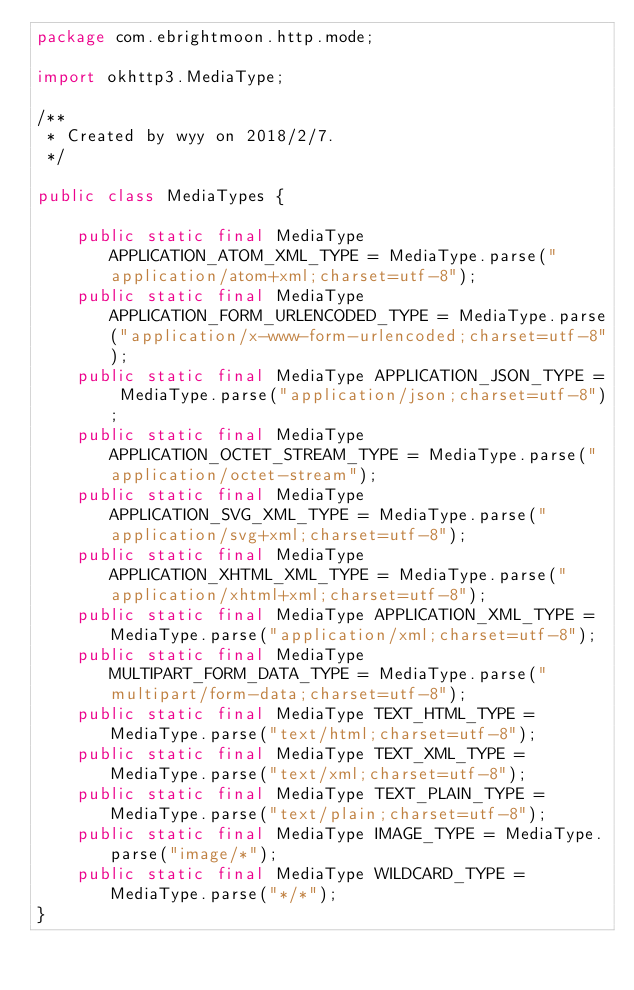<code> <loc_0><loc_0><loc_500><loc_500><_Java_>package com.ebrightmoon.http.mode;

import okhttp3.MediaType;

/**
 * Created by wyy on 2018/2/7.
 */

public class MediaTypes {

    public static final MediaType APPLICATION_ATOM_XML_TYPE = MediaType.parse("application/atom+xml;charset=utf-8");
    public static final MediaType APPLICATION_FORM_URLENCODED_TYPE = MediaType.parse("application/x-www-form-urlencoded;charset=utf-8");
    public static final MediaType APPLICATION_JSON_TYPE = MediaType.parse("application/json;charset=utf-8");
    public static final MediaType APPLICATION_OCTET_STREAM_TYPE = MediaType.parse("application/octet-stream");
    public static final MediaType APPLICATION_SVG_XML_TYPE = MediaType.parse("application/svg+xml;charset=utf-8");
    public static final MediaType APPLICATION_XHTML_XML_TYPE = MediaType.parse("application/xhtml+xml;charset=utf-8");
    public static final MediaType APPLICATION_XML_TYPE = MediaType.parse("application/xml;charset=utf-8");
    public static final MediaType MULTIPART_FORM_DATA_TYPE = MediaType.parse("multipart/form-data;charset=utf-8");
    public static final MediaType TEXT_HTML_TYPE = MediaType.parse("text/html;charset=utf-8");
    public static final MediaType TEXT_XML_TYPE = MediaType.parse("text/xml;charset=utf-8");
    public static final MediaType TEXT_PLAIN_TYPE = MediaType.parse("text/plain;charset=utf-8");
    public static final MediaType IMAGE_TYPE = MediaType.parse("image/*");
    public static final MediaType WILDCARD_TYPE = MediaType.parse("*/*");
}
</code> 